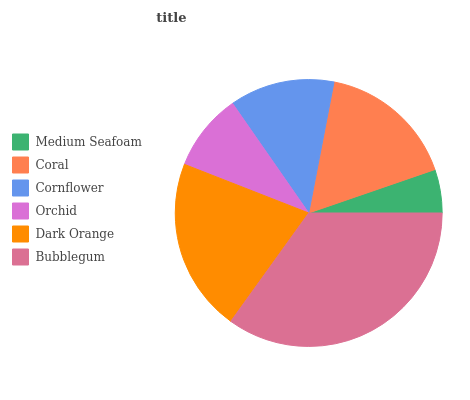Is Medium Seafoam the minimum?
Answer yes or no. Yes. Is Bubblegum the maximum?
Answer yes or no. Yes. Is Coral the minimum?
Answer yes or no. No. Is Coral the maximum?
Answer yes or no. No. Is Coral greater than Medium Seafoam?
Answer yes or no. Yes. Is Medium Seafoam less than Coral?
Answer yes or no. Yes. Is Medium Seafoam greater than Coral?
Answer yes or no. No. Is Coral less than Medium Seafoam?
Answer yes or no. No. Is Coral the high median?
Answer yes or no. Yes. Is Cornflower the low median?
Answer yes or no. Yes. Is Dark Orange the high median?
Answer yes or no. No. Is Coral the low median?
Answer yes or no. No. 